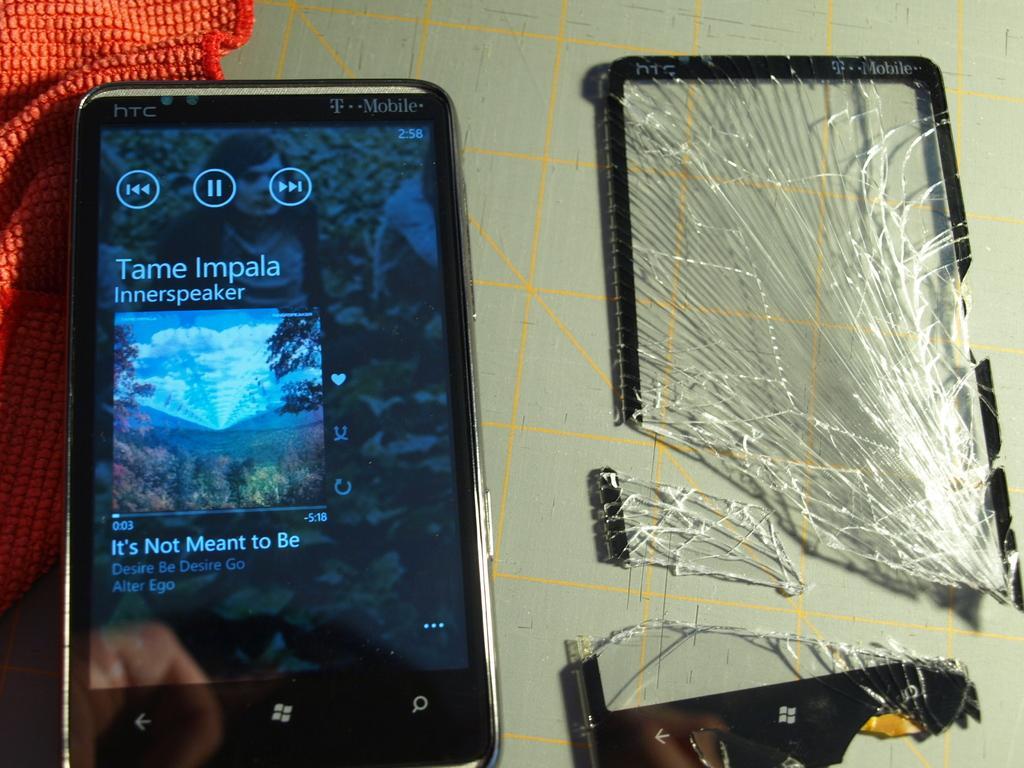Please provide a concise description of this image. In the image we can see a table, on the table there is a cloth and mobile phone and glasses. 